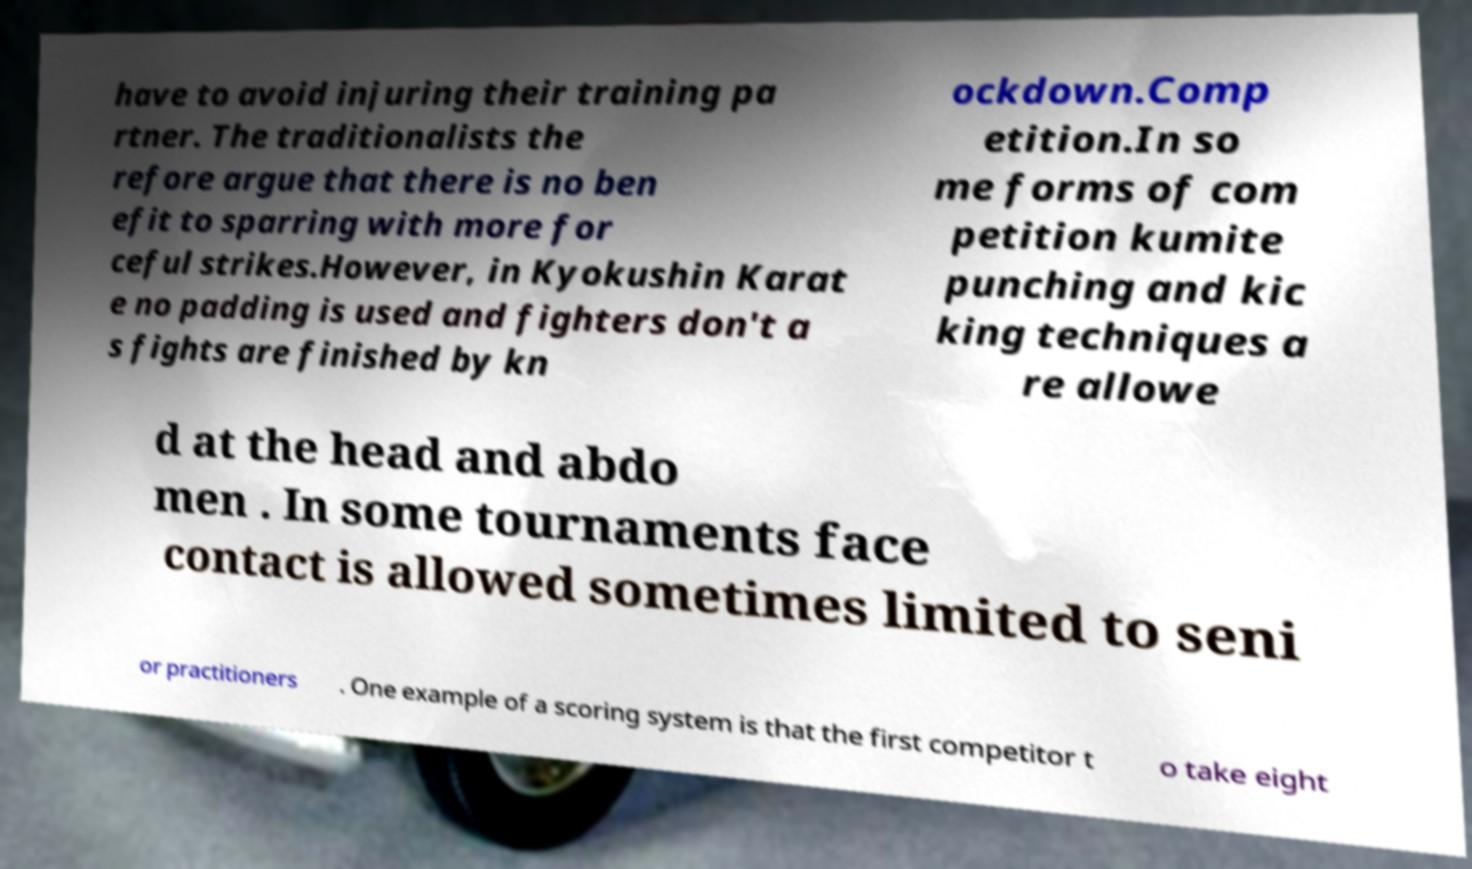I need the written content from this picture converted into text. Can you do that? have to avoid injuring their training pa rtner. The traditionalists the refore argue that there is no ben efit to sparring with more for ceful strikes.However, in Kyokushin Karat e no padding is used and fighters don't a s fights are finished by kn ockdown.Comp etition.In so me forms of com petition kumite punching and kic king techniques a re allowe d at the head and abdo men . In some tournaments face contact is allowed sometimes limited to seni or practitioners . One example of a scoring system is that the first competitor t o take eight 